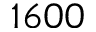<formula> <loc_0><loc_0><loc_500><loc_500>1 6 0 0</formula> 